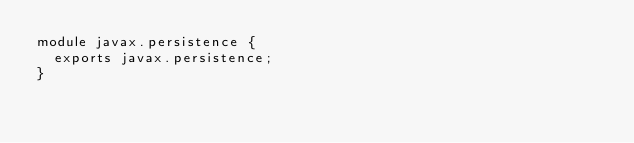Convert code to text. <code><loc_0><loc_0><loc_500><loc_500><_Java_>module javax.persistence {
  exports javax.persistence;
}</code> 